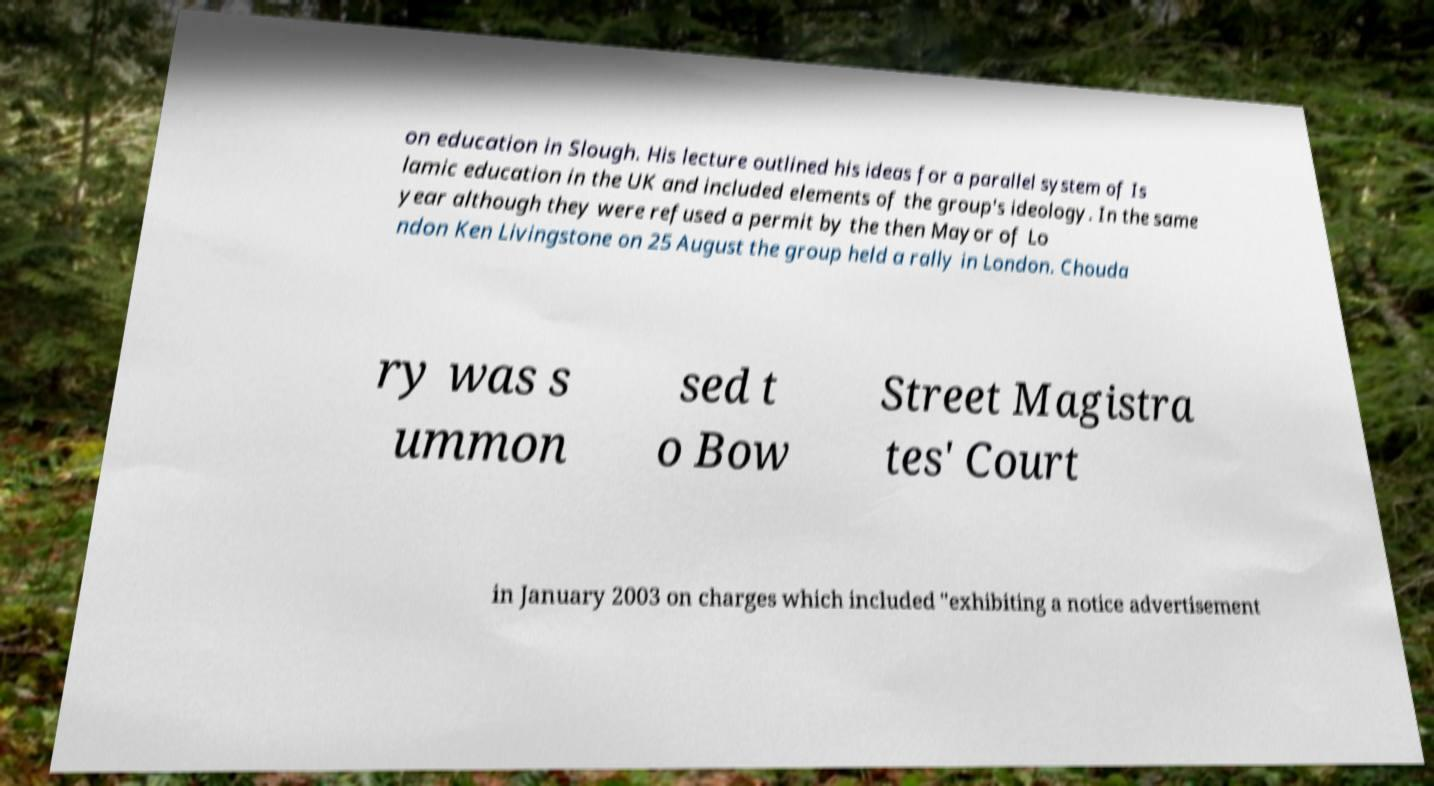What messages or text are displayed in this image? I need them in a readable, typed format. on education in Slough. His lecture outlined his ideas for a parallel system of Is lamic education in the UK and included elements of the group's ideology. In the same year although they were refused a permit by the then Mayor of Lo ndon Ken Livingstone on 25 August the group held a rally in London. Chouda ry was s ummon sed t o Bow Street Magistra tes' Court in January 2003 on charges which included "exhibiting a notice advertisement 